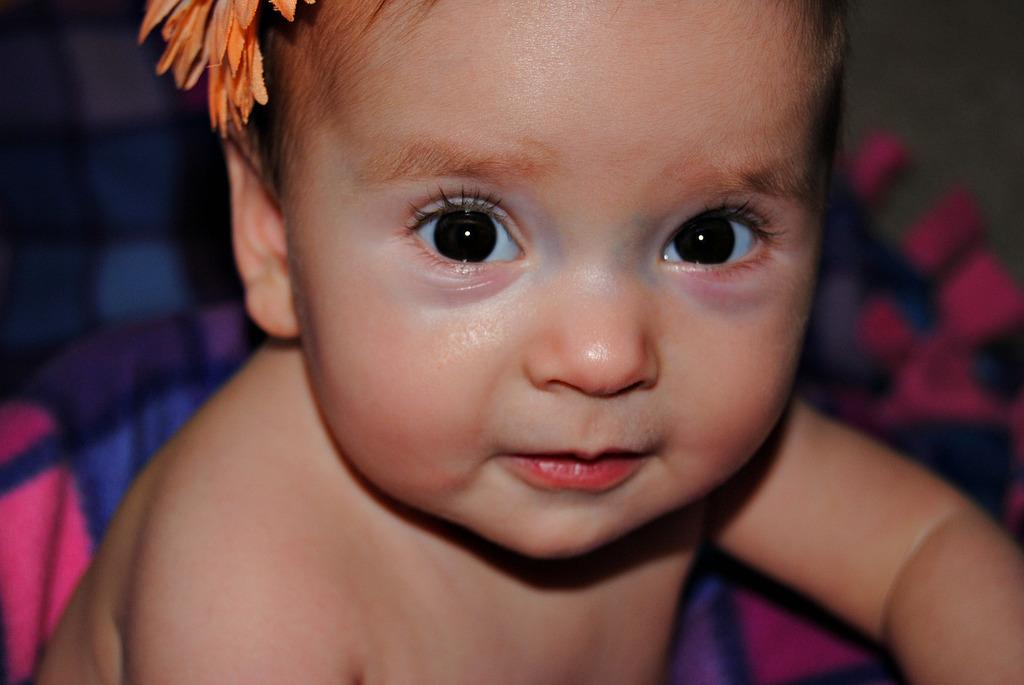What is the main subject of the picture? The main subject of the picture is a baby. What is the baby doing in the picture? The baby is smiling in the picture. Is there any additional accessory or object on the baby? Yes, there is a flower on the baby's head. How many books can be seen in the picture? There are no books present in the picture; it features a baby with a flower on their head. What type of pickle is visible in the picture? There is no pickle present in the picture. 